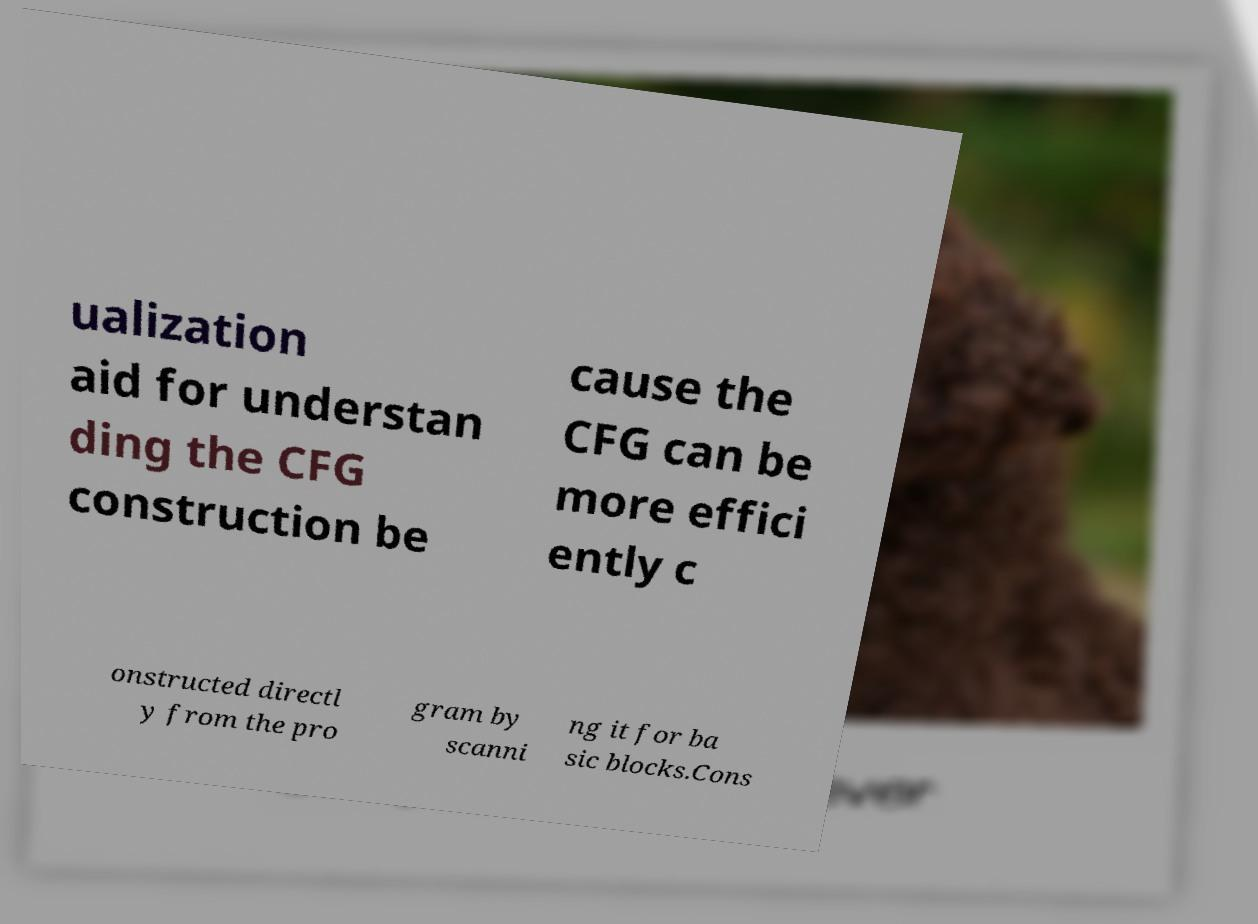What messages or text are displayed in this image? I need them in a readable, typed format. ualization aid for understan ding the CFG construction be cause the CFG can be more effici ently c onstructed directl y from the pro gram by scanni ng it for ba sic blocks.Cons 